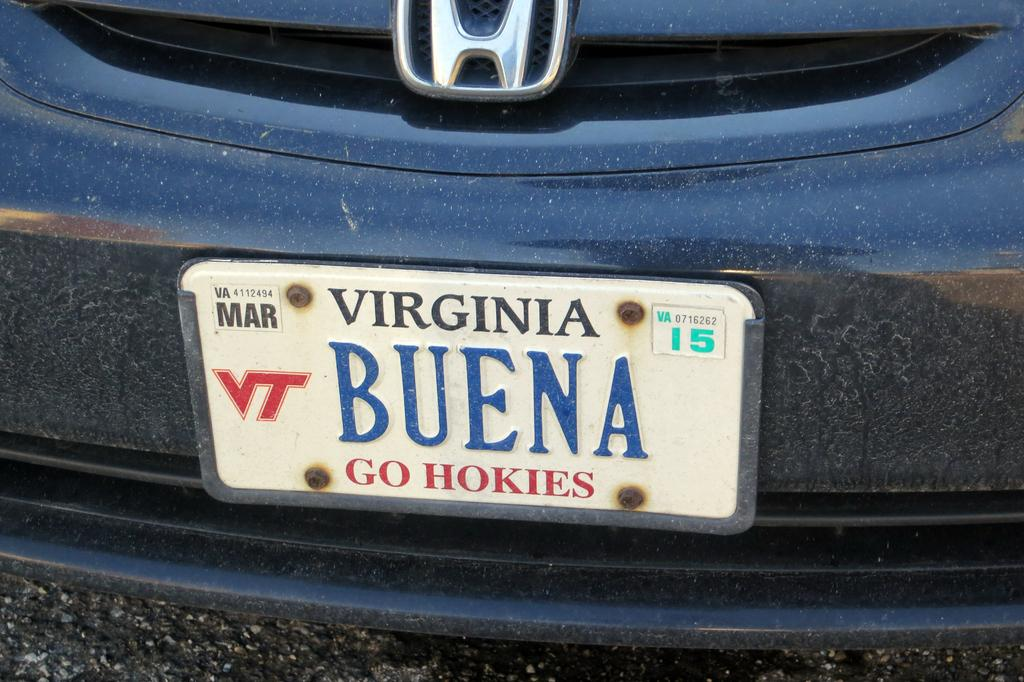<image>
Present a compact description of the photo's key features. Blue car with a license plate that says BUENA in blue. 